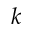<formula> <loc_0><loc_0><loc_500><loc_500>k</formula> 